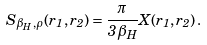Convert formula to latex. <formula><loc_0><loc_0><loc_500><loc_500>S _ { \beta _ { H } , \rho } ( r _ { 1 } , r _ { 2 } ) = \frac { \pi } { 3 \beta _ { H } } X ( r _ { 1 } , r _ { 2 } ) \, .</formula> 